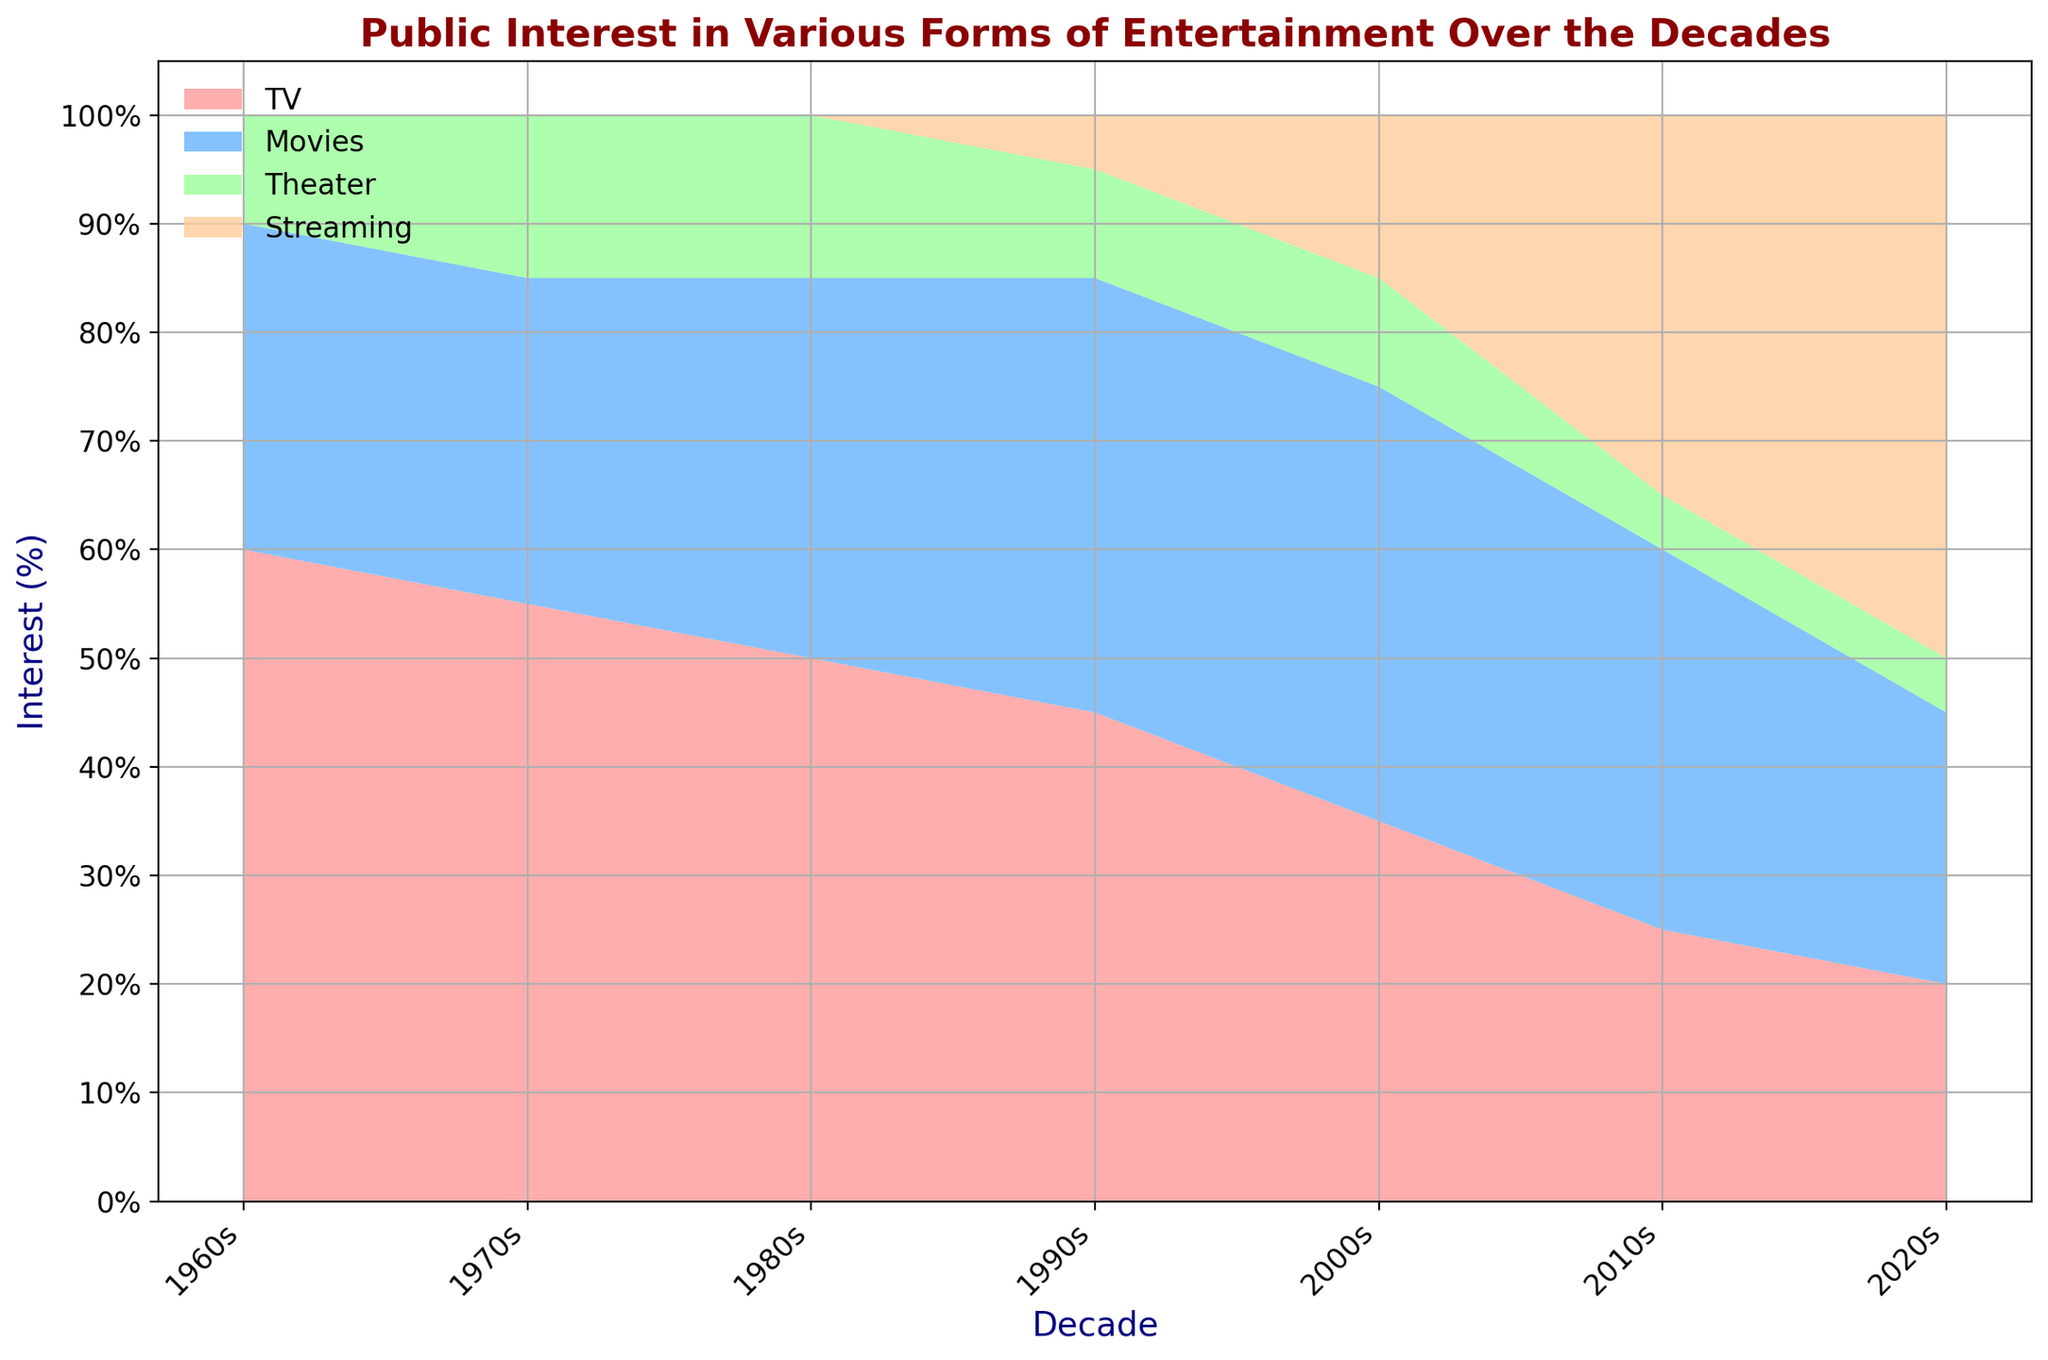What form of entertainment had the highest public interest in the 1960s? The highest area segment in the 1960s is represented by TV, which occupies 60% of the interest.
Answer: TV How did the interest in Movies change from the 1960s to the 2020s? In the 1960s, the interest in Movies was at 30%. By the 2020s, it had decreased to 25%. The interest in Movies had a net decline of 5% over the decades.
Answer: Decreased by 5% Which two forms of entertainment had equal public interest in the 1990s? In the 1990s, TV and Movies are the two forms of entertainment both holding the largest area portions, with Movies at 40% and TV at 45%, making them close in numbers.
Answer: TV and Movies What is the trend in interest for Theater from the 1960s to the 2020s? The area representing Theater remains relatively small but somewhat constant from the 1960s (10%) to the 2020s (5%), with a slight decline over the decades.
Answer: Slightly declined In which decade did Streaming see the most significant increase in public interest? Streaming shows the largest increase in area size between the 2010s and 2020s, with an increase from 35% to 50%.
Answer: 2010s to 2020s What was the combined interest in TV and Movies during the 1980s? During the 1980s, TV had 50% interest and Movies had 35% interest. Therefore, the combined interest is 50% + 35% = 85%.
Answer: 85% How much did the interest in TV drop from the 1960s to the 2000s? TV interest was at 60% in the 1960s and dropped to 35% by the 2000s, resulting in a decline of 60% - 35% = 25%.
Answer: 25% Which form of entertainment surpassed TV in public interest first and in which decade? Streaming first surpassed TV in public interest in the 2010s, with Streaming at 35% and TV at 25%.
Answer: Streaming in 2010s Comparing the 1970s and 2020s, how much more interest did TV have over Streaming in the 1970s compared to Streaming over TV in the 2020s? In the 1970s, TV had 55% interest while Streaming had 0%, resulting in a 55% difference. In the 2020s, Streaming had 50% interest while TV had 20%, resulting in a 30% difference. Therefore, the net difference is 55% - 30% = 25%.
Answer: 25% more in 1970s During which decade was the smallest interest observed in Theater? The smallest interest in Theater, as seen by the smallest area, is in the 2010s and 2020s, both at 5%.
Answer: 2010s and 2020s 